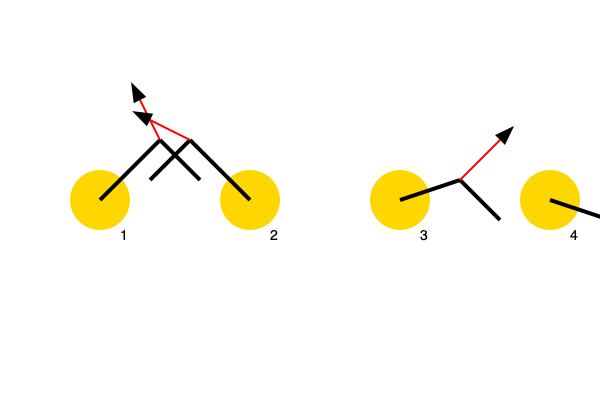Analyze the throwing motion depicted in the sequence of images above. Which phase of the throw experiences the highest rotational velocity of the shoulder joint, and what is the primary muscle group responsible for generating this motion? Additionally, explain how the force vectors change throughout the throwing sequence. Let's break down the throwing motion and analyze each phase:

1. Wind-up (Phase 1):
   - The arm is raised and brought back.
   - Minimal rotational velocity in the shoulder joint.
   - Force vector points upward and slightly backward.

2. Cocking (Phase 2):
   - The arm reaches its maximum external rotation.
   - Rotational velocity increases but is not at its peak.
   - Force vector points backward and slightly downward.

3. Acceleration (Phase 3):
   - The arm rapidly moves forward.
   - This phase experiences the highest rotational velocity of the shoulder joint.
   - The primary muscle group responsible for this motion is the internal rotators of the shoulder, primarily the subscapularis, pectoralis major, and latissimus dorsi.
   - Force vector points forward and upward, indicating the rapid acceleration.

4. Deceleration (Phase 4):
   - The arm continues forward but begins to slow down.
   - Rotational velocity decreases.
   - Force vector points downward and slightly forward, representing the eccentric contraction of the posterior shoulder muscles to decelerate the arm.

The force vectors change direction throughout the sequence:
- They start pointing upward and backward in the wind-up phase.
- Then shift to pointing more directly backward in the cocking phase.
- In the acceleration phase, they abruptly change to point forward and upward.
- Finally, in the deceleration phase, they point downward and slightly forward.

These changes in force vector direction reflect the complex interplay of muscle activations and joint movements required for an efficient throwing motion.
Answer: Acceleration phase; internal rotators (subscapularis, pectoralis major, latissimus dorsi) 